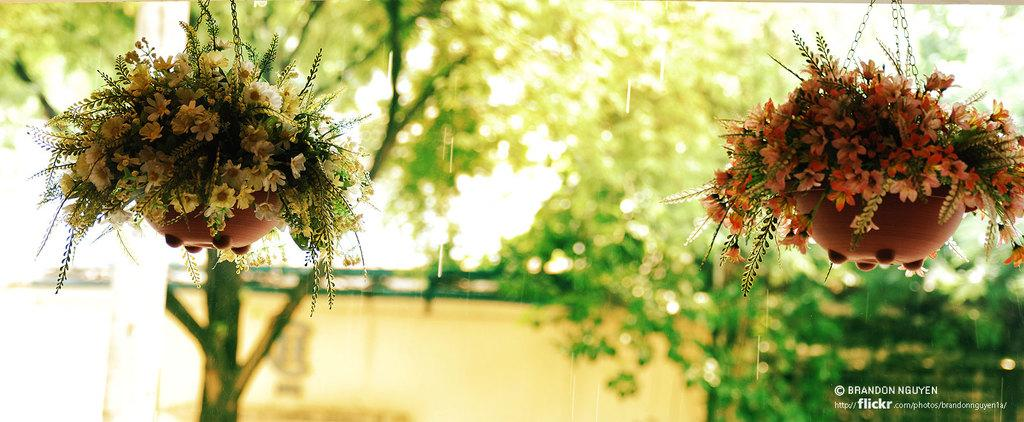What can be seen hanging in the image? There are two hanging flower pots in the image. What can be seen in the background of the image? There are trees and a wall visible in the background of the image. Where is the text located in the image? The text is in the bottom right corner of the image. Can you describe the curtain hanging from the fang in the image? There is no curtain or fang present in the image. 